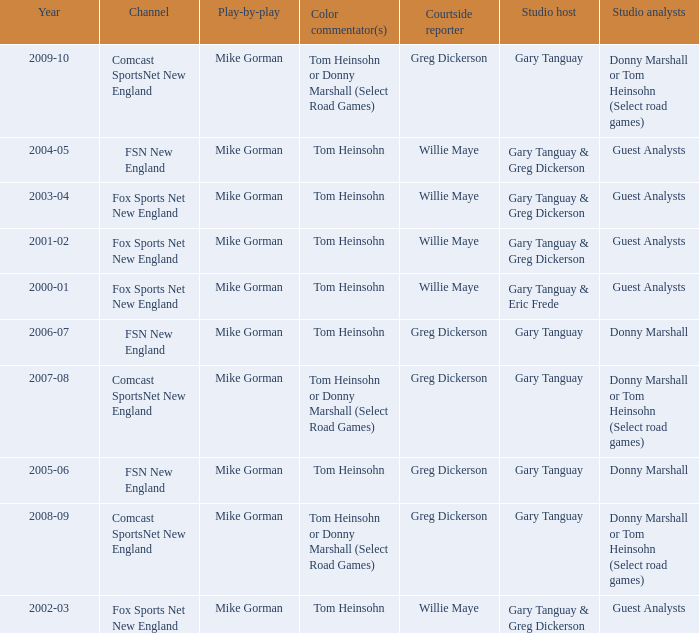Can you parse all the data within this table? {'header': ['Year', 'Channel', 'Play-by-play', 'Color commentator(s)', 'Courtside reporter', 'Studio host', 'Studio analysts'], 'rows': [['2009-10', 'Comcast SportsNet New England', 'Mike Gorman', 'Tom Heinsohn or Donny Marshall (Select Road Games)', 'Greg Dickerson', 'Gary Tanguay', 'Donny Marshall or Tom Heinsohn (Select road games)'], ['2004-05', 'FSN New England', 'Mike Gorman', 'Tom Heinsohn', 'Willie Maye', 'Gary Tanguay & Greg Dickerson', 'Guest Analysts'], ['2003-04', 'Fox Sports Net New England', 'Mike Gorman', 'Tom Heinsohn', 'Willie Maye', 'Gary Tanguay & Greg Dickerson', 'Guest Analysts'], ['2001-02', 'Fox Sports Net New England', 'Mike Gorman', 'Tom Heinsohn', 'Willie Maye', 'Gary Tanguay & Greg Dickerson', 'Guest Analysts'], ['2000-01', 'Fox Sports Net New England', 'Mike Gorman', 'Tom Heinsohn', 'Willie Maye', 'Gary Tanguay & Eric Frede', 'Guest Analysts'], ['2006-07', 'FSN New England', 'Mike Gorman', 'Tom Heinsohn', 'Greg Dickerson', 'Gary Tanguay', 'Donny Marshall'], ['2007-08', 'Comcast SportsNet New England', 'Mike Gorman', 'Tom Heinsohn or Donny Marshall (Select Road Games)', 'Greg Dickerson', 'Gary Tanguay', 'Donny Marshall or Tom Heinsohn (Select road games)'], ['2005-06', 'FSN New England', 'Mike Gorman', 'Tom Heinsohn', 'Greg Dickerson', 'Gary Tanguay', 'Donny Marshall'], ['2008-09', 'Comcast SportsNet New England', 'Mike Gorman', 'Tom Heinsohn or Donny Marshall (Select Road Games)', 'Greg Dickerson', 'Gary Tanguay', 'Donny Marshall or Tom Heinsohn (Select road games)'], ['2002-03', 'Fox Sports Net New England', 'Mike Gorman', 'Tom Heinsohn', 'Willie Maye', 'Gary Tanguay & Greg Dickerson', 'Guest Analysts']]} WHich Play-by-play has a Studio host of gary tanguay, and a Studio analysts of donny marshall? Mike Gorman, Mike Gorman. 